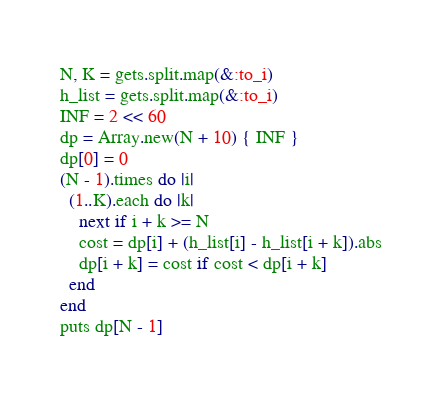<code> <loc_0><loc_0><loc_500><loc_500><_Ruby_>N, K = gets.split.map(&:to_i)
h_list = gets.split.map(&:to_i)
INF = 2 << 60
dp = Array.new(N + 10) { INF }
dp[0] = 0
(N - 1).times do |i|
  (1..K).each do |k|
    next if i + k >= N
    cost = dp[i] + (h_list[i] - h_list[i + k]).abs
    dp[i + k] = cost if cost < dp[i + k]
  end
end
puts dp[N - 1]
</code> 